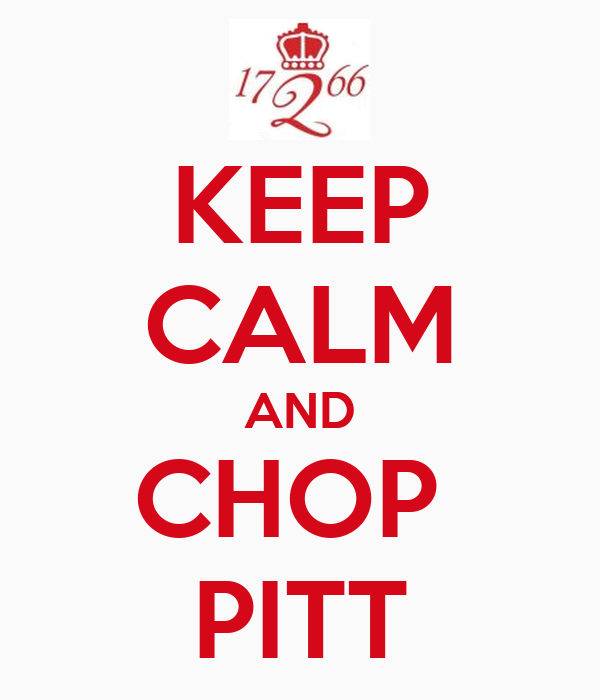What could be the significance of the year "1766" in the emblem? The year "1766" could signify a notable historical event, the founding of an institution, or a significant milestone. Without additional context, it is not clear whether this year is related to a specific historical occurrence, such as the birth of someone important, the establishment of a prominent organization, or a significant event that is known in a particular cultural group. However, its inclusion in the image suggests it is meant to add historical gravity and legitimacy to the message. 